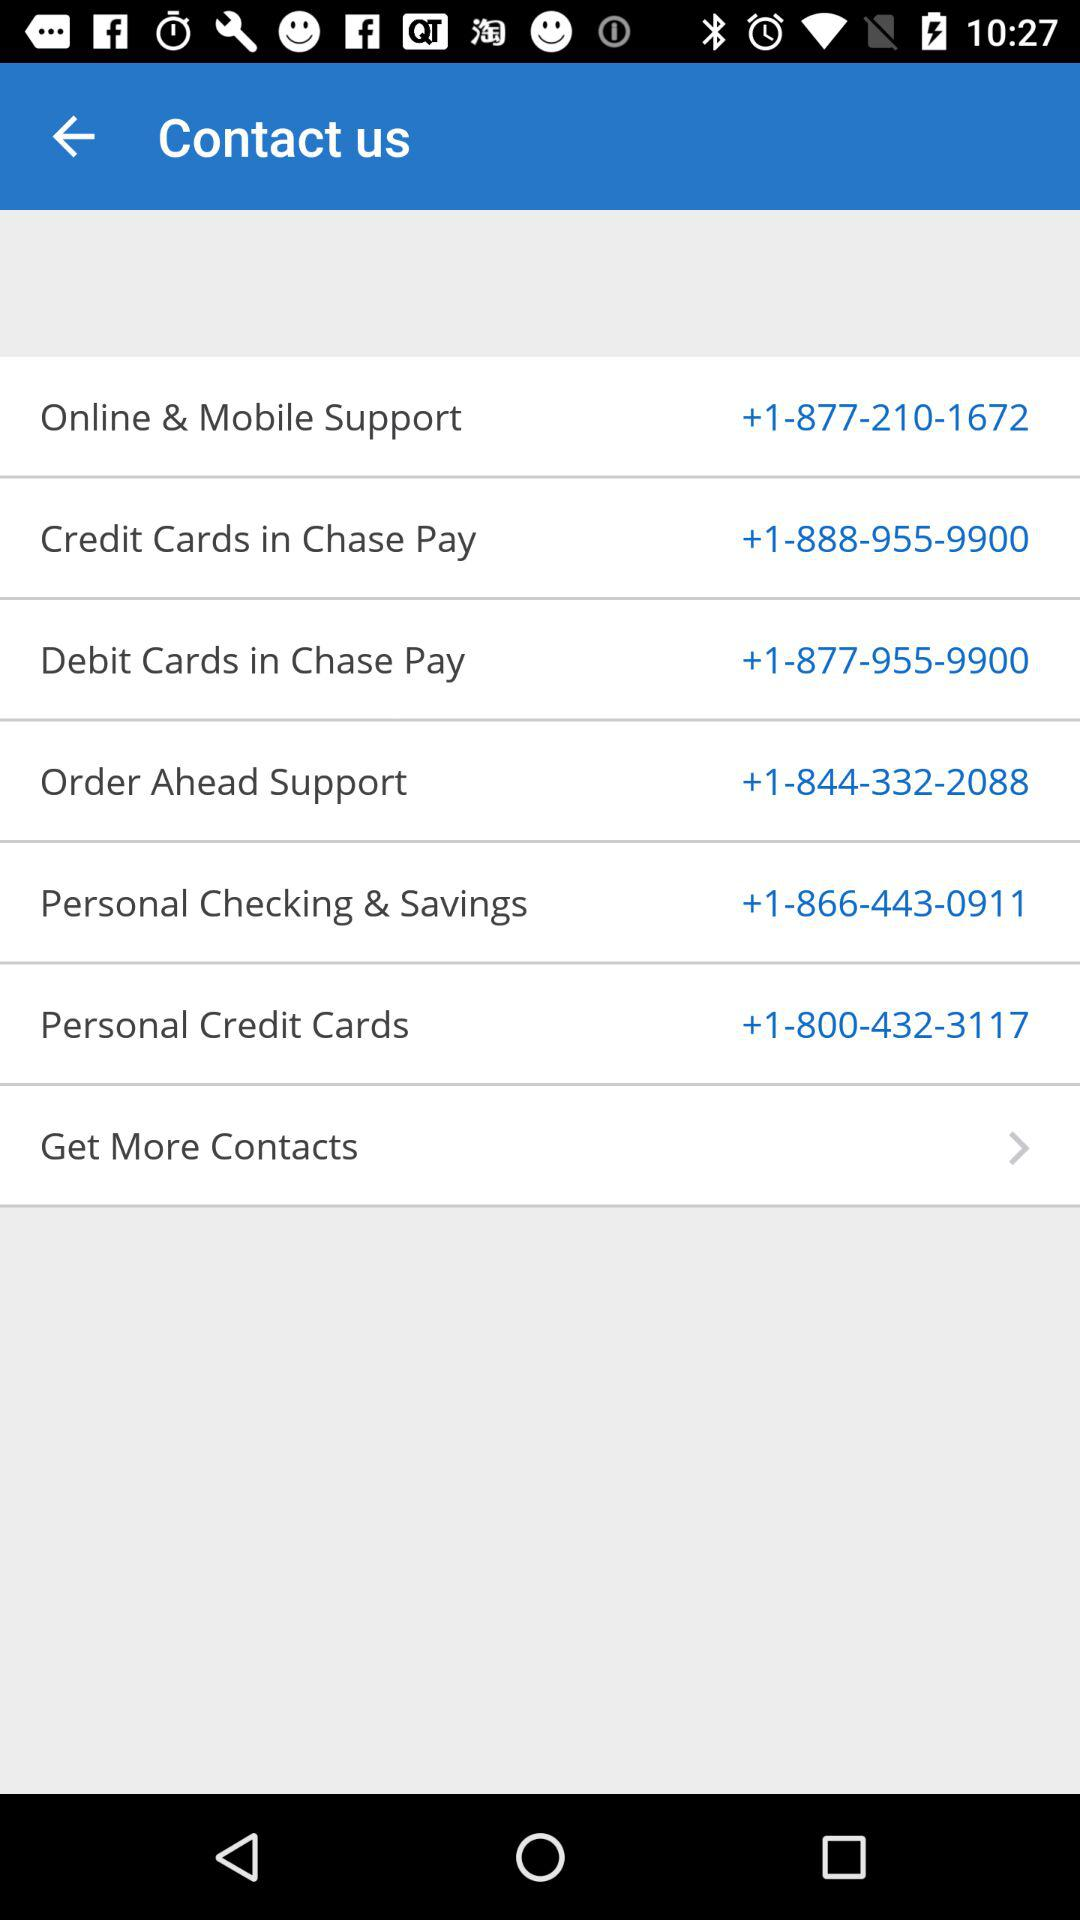What is the contact number for "Online & Mobile Support"? The contact number is +1-877-210-1672. 